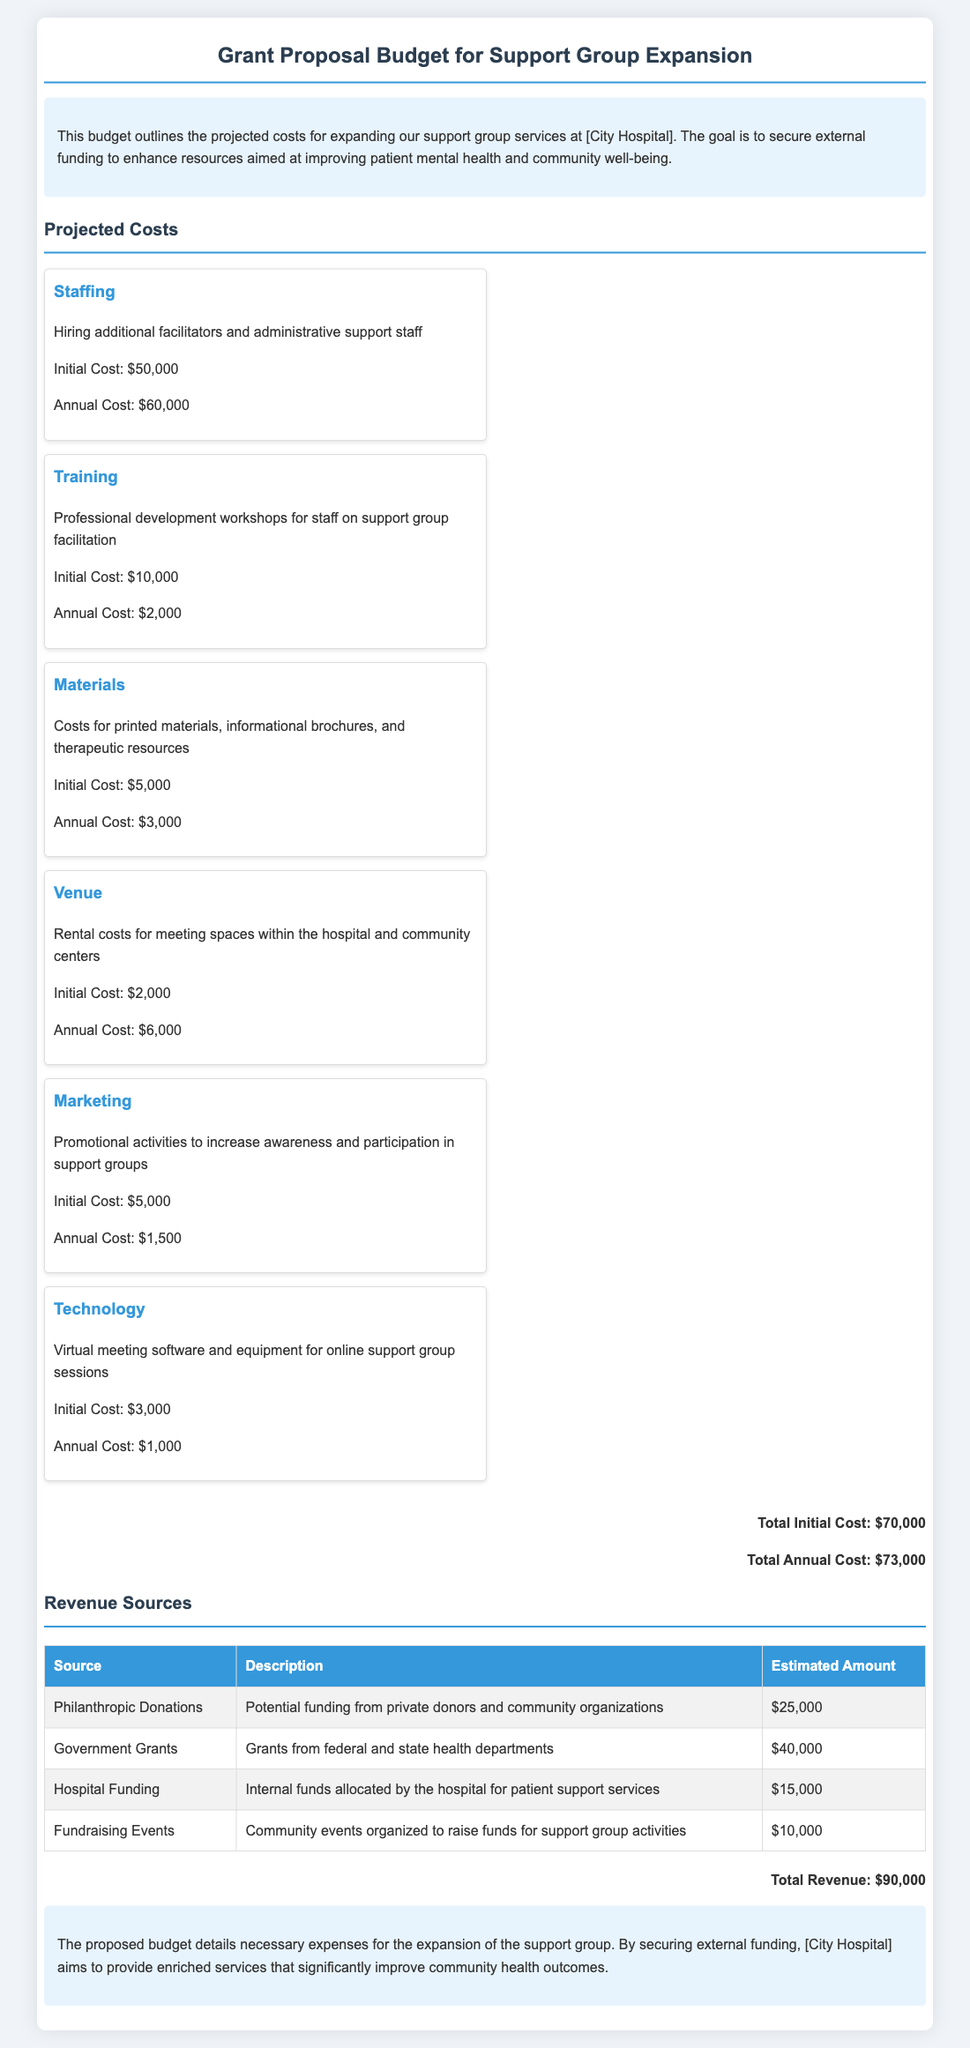what is the initial cost for staffing? The initial cost for staffing is detailed in the budget section, specifically for hiring additional facilitators and administrative support staff.
Answer: $50,000 what are the projected annual costs? The total annual costs are calculated by adding all the annual costs listed in the budget section.
Answer: $73,000 how much funding is expected from government grants? The expected amount from government grants is detailed in the revenue sources table.
Answer: $40,000 what is the total initial cost for the project? The total initial cost is provided at the end of the projected costs section, combining all initial expenses.
Answer: $70,000 how much is allocated for training annually? The annual cost for training is found in the projected costs section, indicating the budget for professional development workshops.
Answer: $2,000 what is the estimated amount from philanthropic donations? The revenue sources table specifies the estimated amount expected from philanthropic donations as part of the funding.
Answer: $25,000 what type of events are planned for additional fundraising? The document specifies that community events are organized for supplementary fundraising efforts.
Answer: Fundraising Events how much is allocated for marketing costs? The budget section includes marketing costs within the projected expenses for promoting support group awareness.
Answer: $5,000 what is the total revenue amount? The total revenue is calculated from all listed revenue sources, presented at the end of the revenue section.
Answer: $90,000 